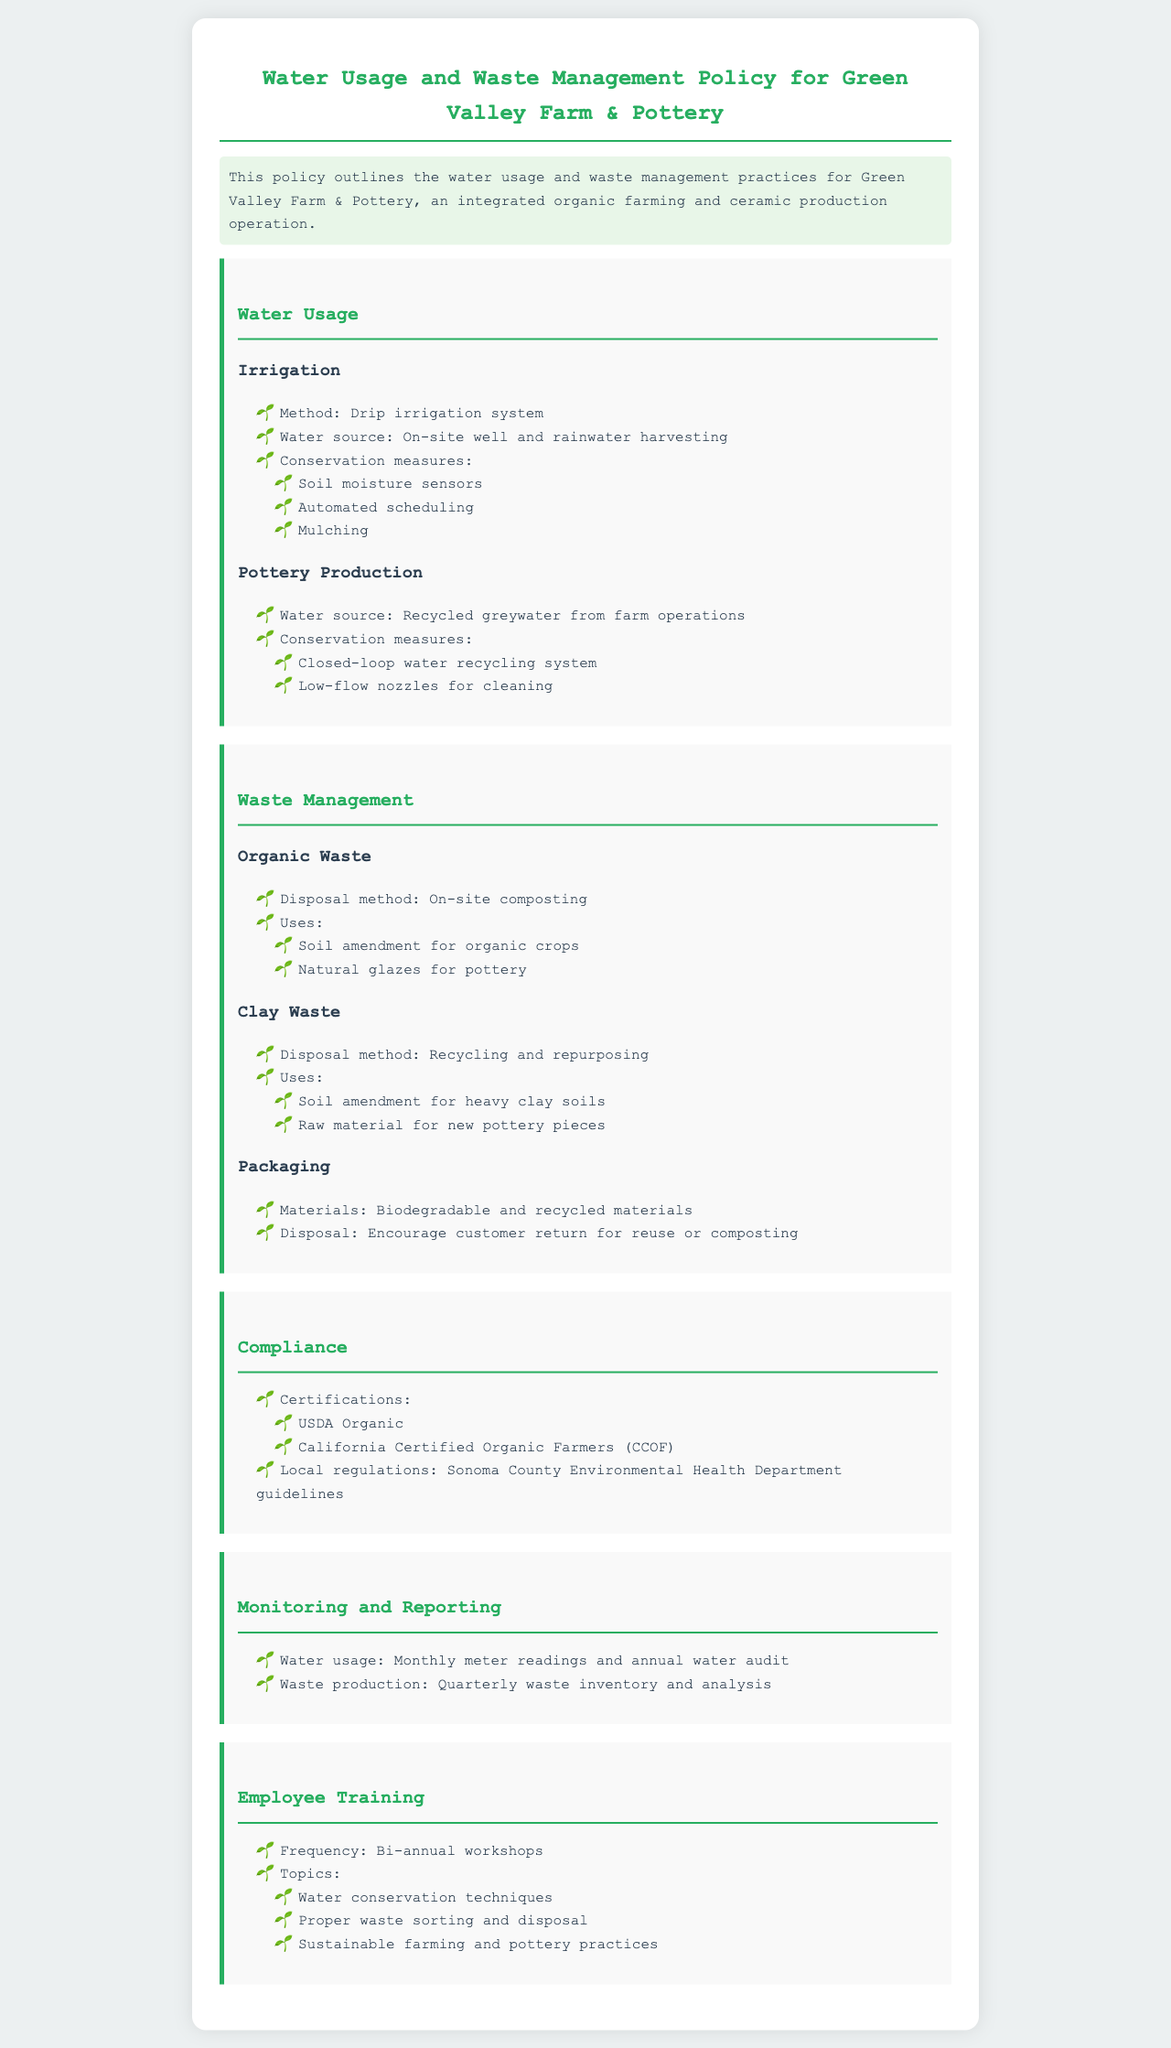What is the method of irrigation used? The document states that the irrigation method employed is drip irrigation.
Answer: Drip irrigation What is the water source for pottery production? The water for pottery production is sourced from recycled greywater from farm operations.
Answer: Recycled greywater What type of waste is disposed of via on-site composting? The organic waste from farm operations is managed through on-site composting.
Answer: Organic waste What are the certifications mentioned in the policy? The certifications include USDA Organic and California Certified Organic Farmers (CCOF).
Answer: USDA Organic, CCOF How frequently are employee training workshops held? The policy indicates that employee training workshops occur bi-annually.
Answer: Bi-annual What conservation measure is used in irrigation? One conservation measure used in irrigation is soil moisture sensors.
Answer: Soil moisture sensors How is clay waste managed according to the policy? Clay waste is managed through recycling and repurposing, as outlined in the document.
Answer: Recycling and repurposing What is the packaging material mentioned? The document refers to the use of biodegradable and recycled materials for packaging.
Answer: Biodegradable and recycled materials How often is a water audit conducted? The policy specifies that an annual water audit is part of the monitoring process.
Answer: Annual 